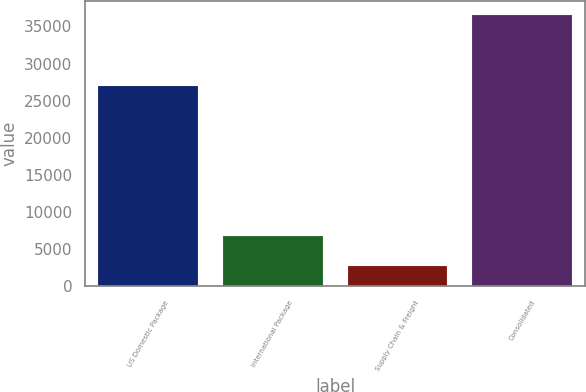<chart> <loc_0><loc_0><loc_500><loc_500><bar_chart><fcel>US Domestic Package<fcel>International Package<fcel>Supply Chain & Freight<fcel>Consolidated<nl><fcel>26960<fcel>6809<fcel>2813<fcel>36582<nl></chart> 